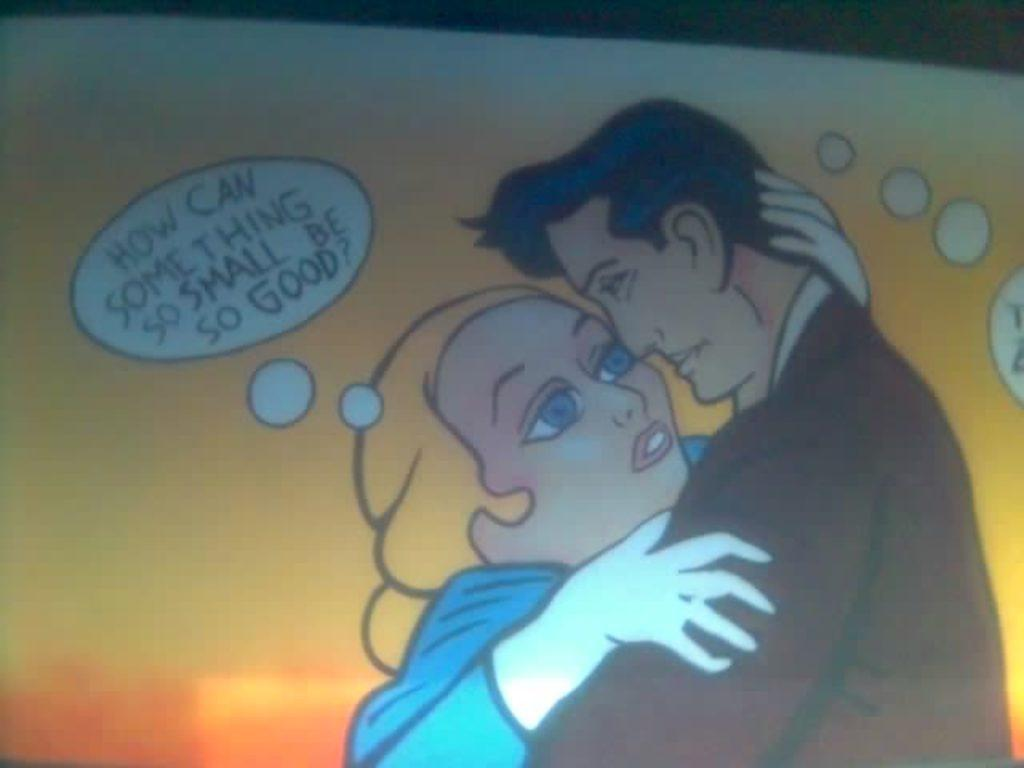How many people are in the image? There are two persons in the image. What are the two persons doing in the image? The two persons are standing and hugging. What type of star can be seen in the image? There is no star present in the image. What drink is being held by one of the persons in the image? There is no drink visible in the image. 